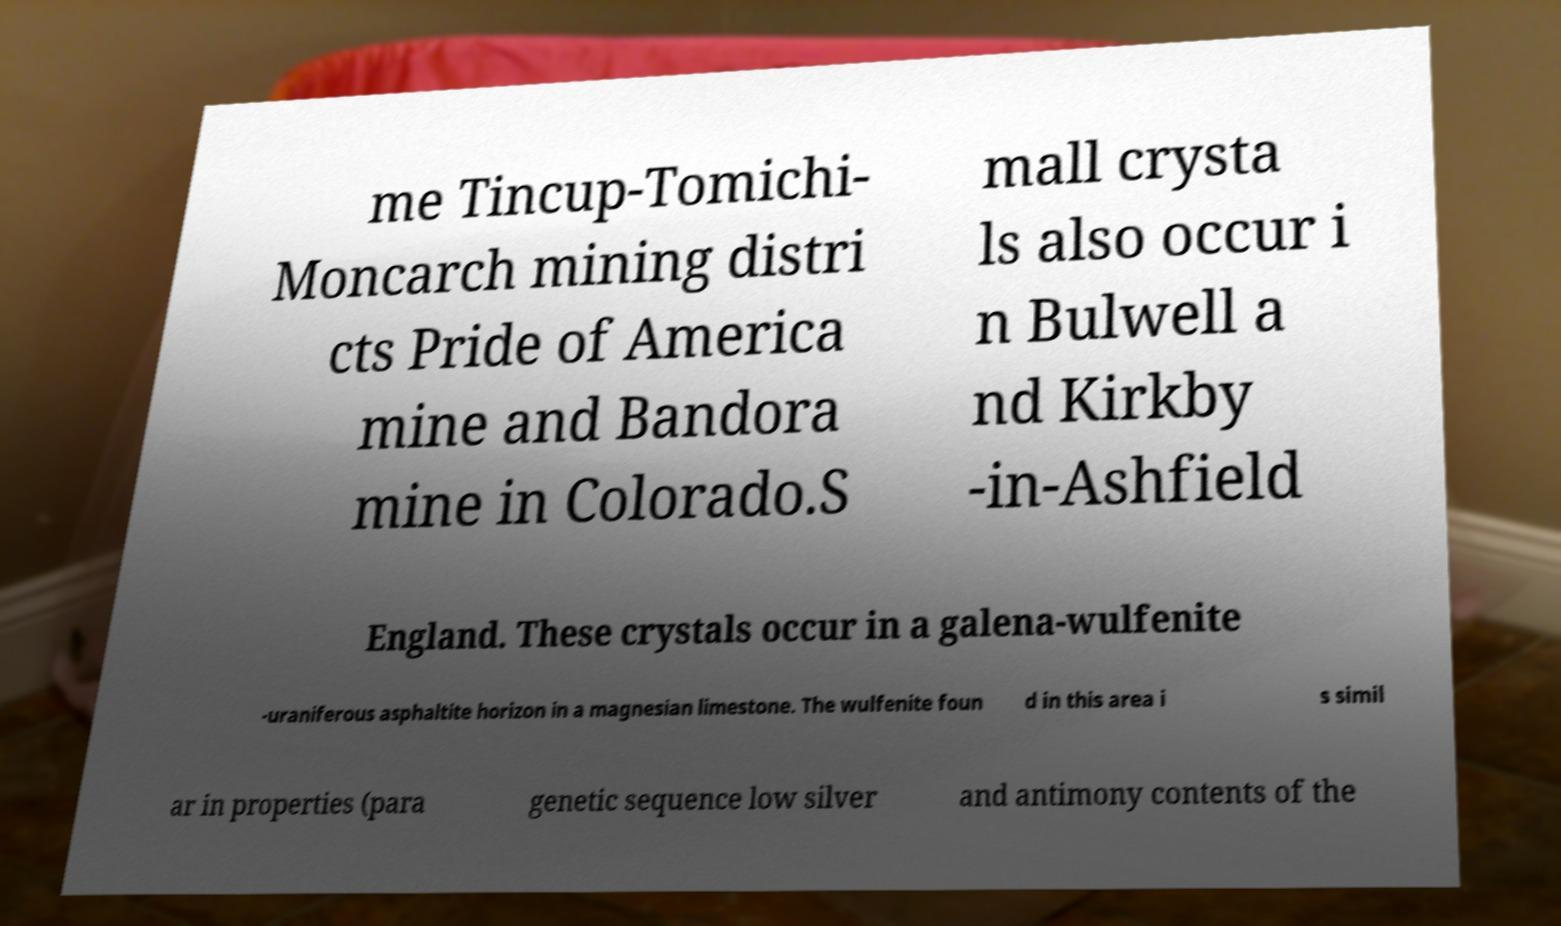Please identify and transcribe the text found in this image. me Tincup-Tomichi- Moncarch mining distri cts Pride of America mine and Bandora mine in Colorado.S mall crysta ls also occur i n Bulwell a nd Kirkby -in-Ashfield England. These crystals occur in a galena-wulfenite -uraniferous asphaltite horizon in a magnesian limestone. The wulfenite foun d in this area i s simil ar in properties (para genetic sequence low silver and antimony contents of the 